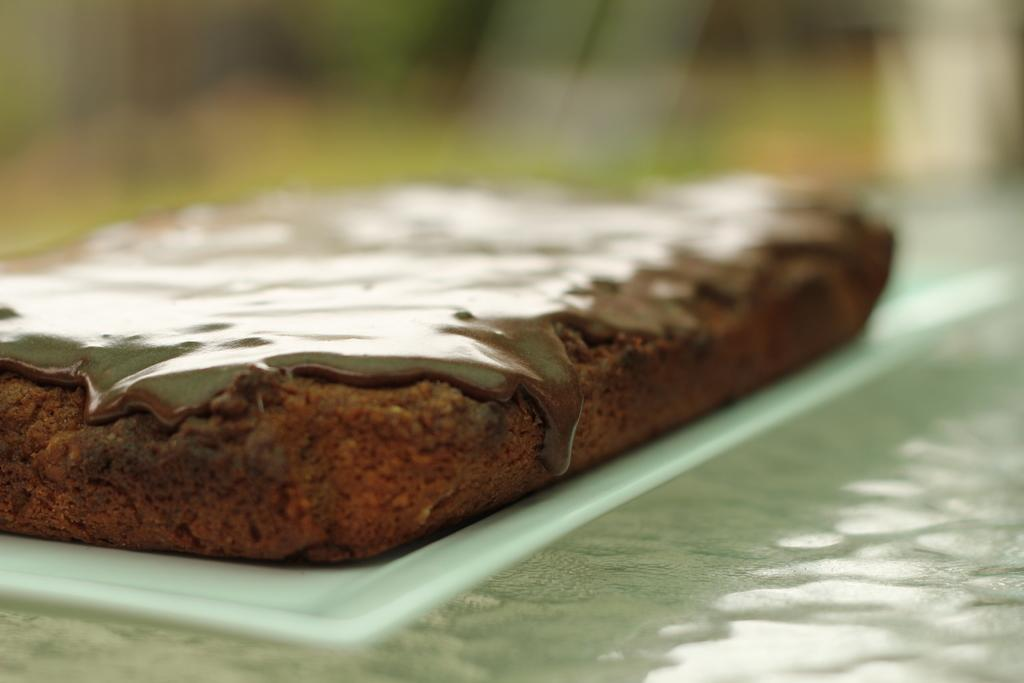What can be observed about the background of the image? The background of the image is blurred. What type of table is visible in the image? There is a glass table at the bottom of the image. What food item is present on a plate in the image? There is a chocolate brownie on a plate in the middle of the image. Can you tell me how many balloons are floating above the brownie in the image? There are no balloons present in the image; it only features a chocolate brownie on a plate. Is there a verse written on the glass table in the image? There is no verse written on the glass table in the image; it only features a chocolate brownie on a plate. 